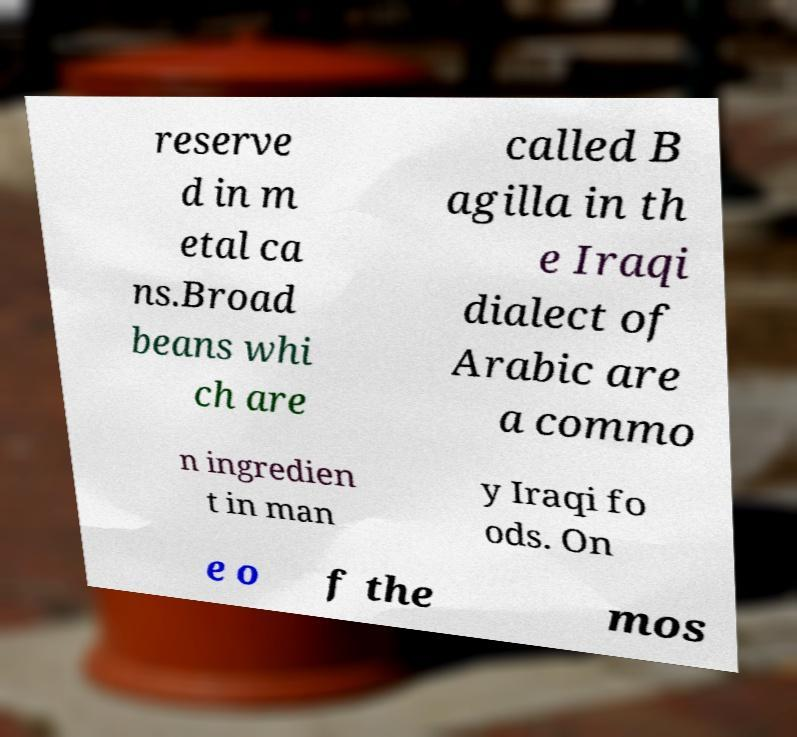Could you assist in decoding the text presented in this image and type it out clearly? reserve d in m etal ca ns.Broad beans whi ch are called B agilla in th e Iraqi dialect of Arabic are a commo n ingredien t in man y Iraqi fo ods. On e o f the mos 